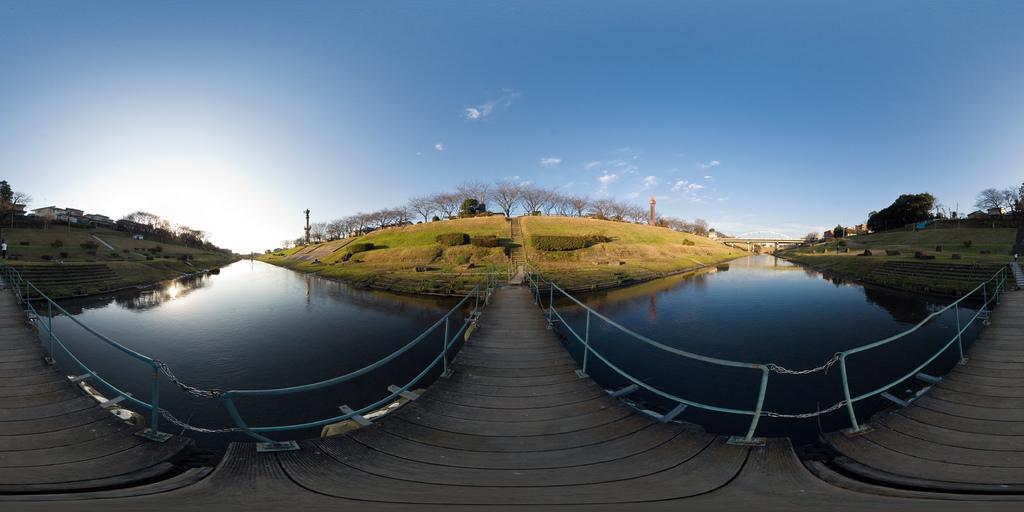Please provide a concise description of this image. These are the water. I think this is a wooden bridge. These are the kind of barricades. I can see the trees. These are the bushes. Here is the sky. I think these are the stairs. I can see the buildings. This looks like a bridge. 